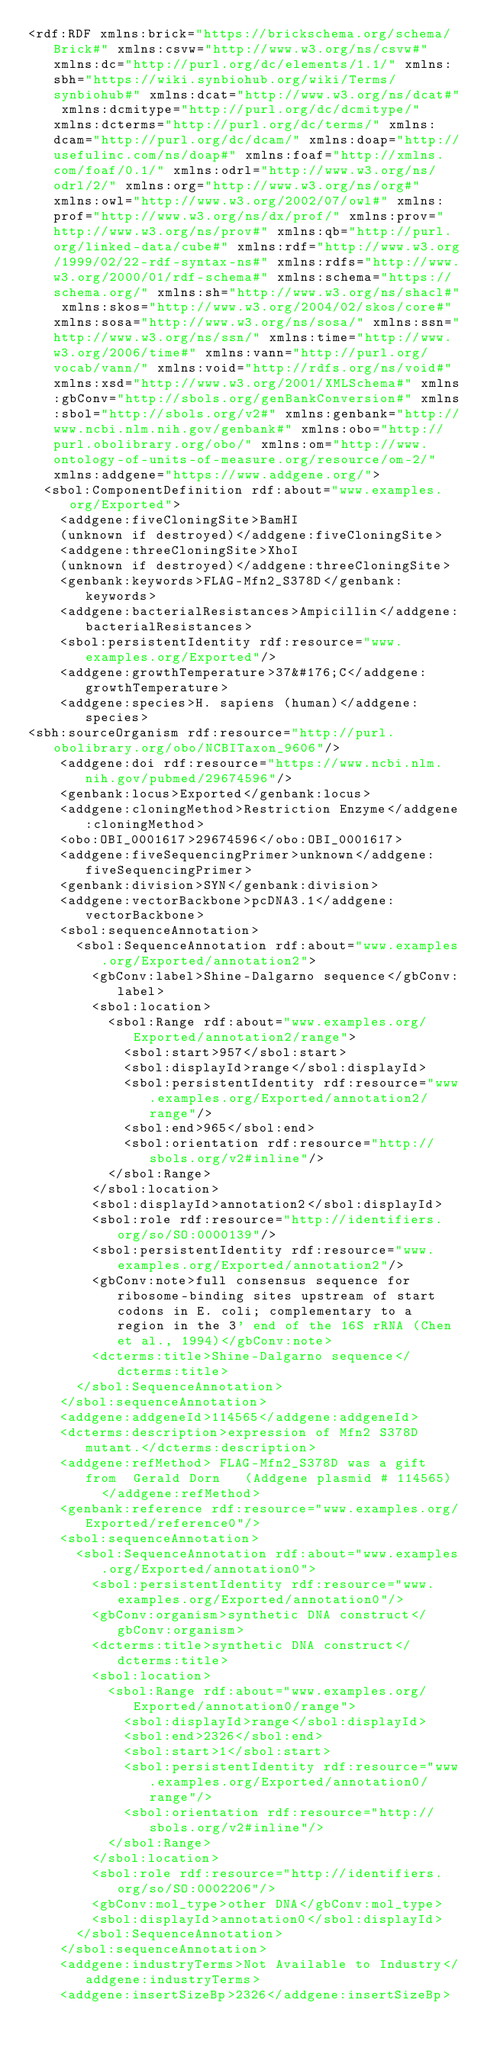<code> <loc_0><loc_0><loc_500><loc_500><_XML_><rdf:RDF xmlns:brick="https://brickschema.org/schema/Brick#" xmlns:csvw="http://www.w3.org/ns/csvw#" xmlns:dc="http://purl.org/dc/elements/1.1/" xmlns:sbh="https://wiki.synbiohub.org/wiki/Terms/synbiohub#" xmlns:dcat="http://www.w3.org/ns/dcat#" xmlns:dcmitype="http://purl.org/dc/dcmitype/" xmlns:dcterms="http://purl.org/dc/terms/" xmlns:dcam="http://purl.org/dc/dcam/" xmlns:doap="http://usefulinc.com/ns/doap#" xmlns:foaf="http://xmlns.com/foaf/0.1/" xmlns:odrl="http://www.w3.org/ns/odrl/2/" xmlns:org="http://www.w3.org/ns/org#" xmlns:owl="http://www.w3.org/2002/07/owl#" xmlns:prof="http://www.w3.org/ns/dx/prof/" xmlns:prov="http://www.w3.org/ns/prov#" xmlns:qb="http://purl.org/linked-data/cube#" xmlns:rdf="http://www.w3.org/1999/02/22-rdf-syntax-ns#" xmlns:rdfs="http://www.w3.org/2000/01/rdf-schema#" xmlns:schema="https://schema.org/" xmlns:sh="http://www.w3.org/ns/shacl#" xmlns:skos="http://www.w3.org/2004/02/skos/core#" xmlns:sosa="http://www.w3.org/ns/sosa/" xmlns:ssn="http://www.w3.org/ns/ssn/" xmlns:time="http://www.w3.org/2006/time#" xmlns:vann="http://purl.org/vocab/vann/" xmlns:void="http://rdfs.org/ns/void#" xmlns:xsd="http://www.w3.org/2001/XMLSchema#" xmlns:gbConv="http://sbols.org/genBankConversion#" xmlns:sbol="http://sbols.org/v2#" xmlns:genbank="http://www.ncbi.nlm.nih.gov/genbank#" xmlns:obo="http://purl.obolibrary.org/obo/" xmlns:om="http://www.ontology-of-units-of-measure.org/resource/om-2/" xmlns:addgene="https://www.addgene.org/">
  <sbol:ComponentDefinition rdf:about="www.examples.org/Exported">
    <addgene:fiveCloningSite>BamHI
    (unknown if destroyed)</addgene:fiveCloningSite>
    <addgene:threeCloningSite>XhoI
    (unknown if destroyed)</addgene:threeCloningSite>
    <genbank:keywords>FLAG-Mfn2_S378D</genbank:keywords>
    <addgene:bacterialResistances>Ampicillin</addgene:bacterialResistances>
    <sbol:persistentIdentity rdf:resource="www.examples.org/Exported"/>
    <addgene:growthTemperature>37&#176;C</addgene:growthTemperature>
    <addgene:species>H. sapiens (human)</addgene:species>
<sbh:sourceOrganism rdf:resource="http://purl.obolibrary.org/obo/NCBITaxon_9606"/>
    <addgene:doi rdf:resource="https://www.ncbi.nlm.nih.gov/pubmed/29674596"/>
    <genbank:locus>Exported</genbank:locus>
    <addgene:cloningMethod>Restriction Enzyme</addgene:cloningMethod>
    <obo:OBI_0001617>29674596</obo:OBI_0001617>
    <addgene:fiveSequencingPrimer>unknown</addgene:fiveSequencingPrimer>
    <genbank:division>SYN</genbank:division>
    <addgene:vectorBackbone>pcDNA3.1</addgene:vectorBackbone>
    <sbol:sequenceAnnotation>
      <sbol:SequenceAnnotation rdf:about="www.examples.org/Exported/annotation2">
        <gbConv:label>Shine-Dalgarno sequence</gbConv:label>
        <sbol:location>
          <sbol:Range rdf:about="www.examples.org/Exported/annotation2/range">
            <sbol:start>957</sbol:start>
            <sbol:displayId>range</sbol:displayId>
            <sbol:persistentIdentity rdf:resource="www.examples.org/Exported/annotation2/range"/>
            <sbol:end>965</sbol:end>
            <sbol:orientation rdf:resource="http://sbols.org/v2#inline"/>
          </sbol:Range>
        </sbol:location>
        <sbol:displayId>annotation2</sbol:displayId>
        <sbol:role rdf:resource="http://identifiers.org/so/SO:0000139"/>
        <sbol:persistentIdentity rdf:resource="www.examples.org/Exported/annotation2"/>
        <gbConv:note>full consensus sequence for ribosome-binding sites upstream of start codons in E. coli; complementary to a region in the 3' end of the 16S rRNA (Chen et al., 1994)</gbConv:note>
        <dcterms:title>Shine-Dalgarno sequence</dcterms:title>
      </sbol:SequenceAnnotation>
    </sbol:sequenceAnnotation>
    <addgene:addgeneId>114565</addgene:addgeneId>
    <dcterms:description>expression of Mfn2 S378D mutant.</dcterms:description>
    <addgene:refMethod> FLAG-Mfn2_S378D was a gift from  Gerald Dorn   (Addgene plasmid # 114565)   </addgene:refMethod>
    <genbank:reference rdf:resource="www.examples.org/Exported/reference0"/>
    <sbol:sequenceAnnotation>
      <sbol:SequenceAnnotation rdf:about="www.examples.org/Exported/annotation0">
        <sbol:persistentIdentity rdf:resource="www.examples.org/Exported/annotation0"/>
        <gbConv:organism>synthetic DNA construct</gbConv:organism>
        <dcterms:title>synthetic DNA construct</dcterms:title>
        <sbol:location>
          <sbol:Range rdf:about="www.examples.org/Exported/annotation0/range">
            <sbol:displayId>range</sbol:displayId>
            <sbol:end>2326</sbol:end>
            <sbol:start>1</sbol:start>
            <sbol:persistentIdentity rdf:resource="www.examples.org/Exported/annotation0/range"/>
            <sbol:orientation rdf:resource="http://sbols.org/v2#inline"/>
          </sbol:Range>
        </sbol:location>
        <sbol:role rdf:resource="http://identifiers.org/so/SO:0002206"/>
        <gbConv:mol_type>other DNA</gbConv:mol_type>
        <sbol:displayId>annotation0</sbol:displayId>
      </sbol:SequenceAnnotation>
    </sbol:sequenceAnnotation>
    <addgene:industryTerms>Not Available to Industry</addgene:industryTerms>
    <addgene:insertSizeBp>2326</addgene:insertSizeBp></code> 